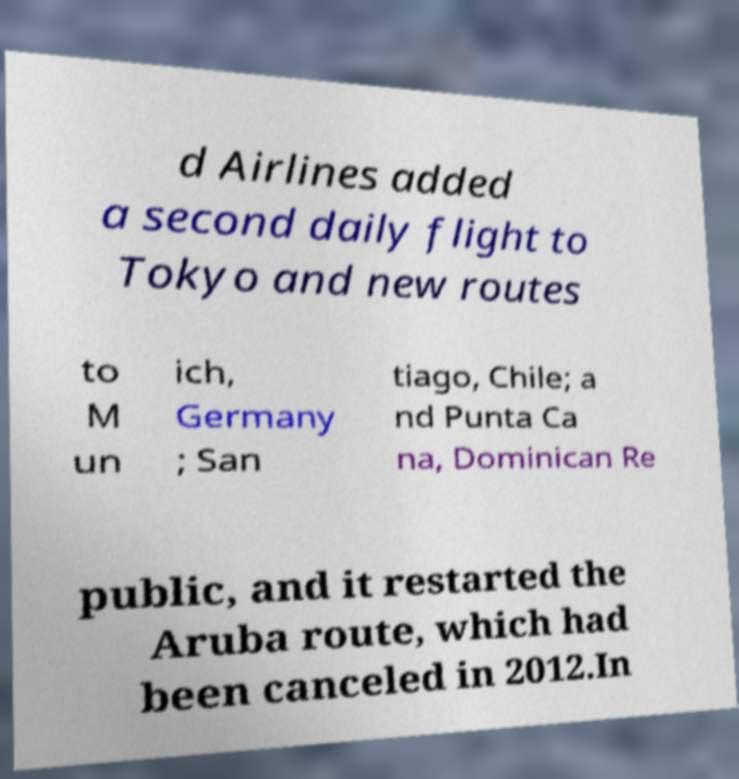Can you read and provide the text displayed in the image?This photo seems to have some interesting text. Can you extract and type it out for me? d Airlines added a second daily flight to Tokyo and new routes to M un ich, Germany ; San tiago, Chile; a nd Punta Ca na, Dominican Re public, and it restarted the Aruba route, which had been canceled in 2012.In 